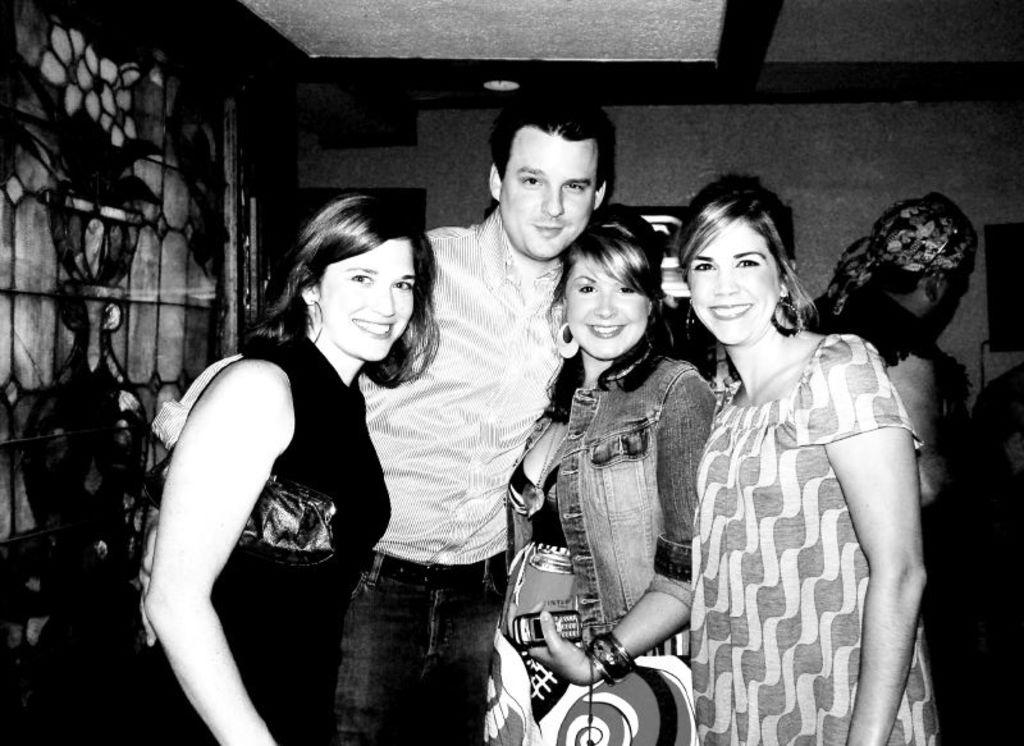Who is present in the image? There is a man and a woman in the image. What are the facial expressions of the people in the image? Both the man and woman are smiling in the image. What can be seen in the background of the image? There is a wall in the background of the image. What is the color scheme of the image? The image is black and white. What type of cow can be seen participating in the event in the image? There is no cow or event present in the image; it features a man and a woman smiling in a black and white setting. What kind of apparatus is being used by the man in the image? There is no apparatus visible in the image; the man is simply standing and smiling. 